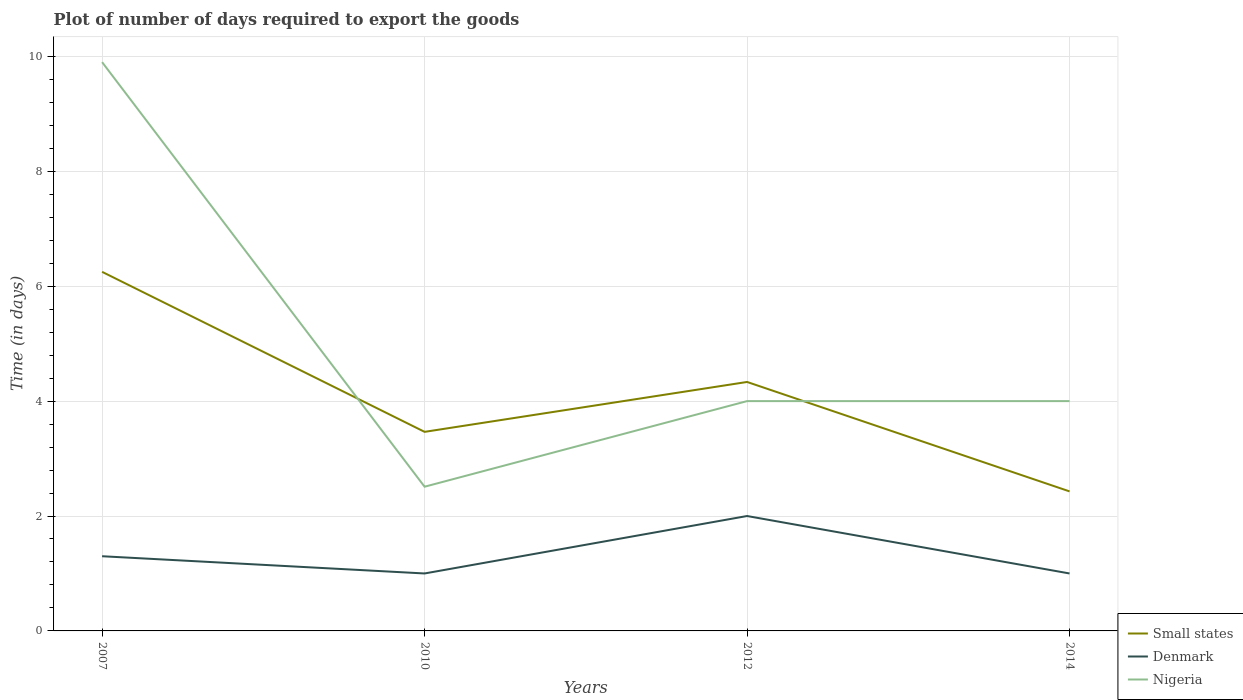How many different coloured lines are there?
Give a very brief answer. 3. Is the number of lines equal to the number of legend labels?
Keep it short and to the point. Yes. Across all years, what is the maximum time required to export goods in Small states?
Offer a terse response. 2.43. What is the total time required to export goods in Small states in the graph?
Ensure brevity in your answer.  3.82. What is the difference between the highest and the second highest time required to export goods in Nigeria?
Provide a succinct answer. 7.39. What is the difference between the highest and the lowest time required to export goods in Denmark?
Give a very brief answer. 1. What is the difference between two consecutive major ticks on the Y-axis?
Your answer should be compact. 2. What is the title of the graph?
Your response must be concise. Plot of number of days required to export the goods. Does "Algeria" appear as one of the legend labels in the graph?
Provide a short and direct response. No. What is the label or title of the X-axis?
Provide a short and direct response. Years. What is the label or title of the Y-axis?
Your answer should be very brief. Time (in days). What is the Time (in days) of Small states in 2007?
Your answer should be very brief. 6.25. What is the Time (in days) of Small states in 2010?
Provide a short and direct response. 3.46. What is the Time (in days) in Nigeria in 2010?
Your response must be concise. 2.51. What is the Time (in days) in Small states in 2012?
Your answer should be very brief. 4.33. What is the Time (in days) of Nigeria in 2012?
Your answer should be very brief. 4. What is the Time (in days) in Small states in 2014?
Give a very brief answer. 2.43. What is the Time (in days) in Denmark in 2014?
Give a very brief answer. 1. Across all years, what is the maximum Time (in days) in Small states?
Give a very brief answer. 6.25. Across all years, what is the minimum Time (in days) of Small states?
Your answer should be very brief. 2.43. Across all years, what is the minimum Time (in days) of Denmark?
Your response must be concise. 1. Across all years, what is the minimum Time (in days) of Nigeria?
Your answer should be very brief. 2.51. What is the total Time (in days) of Small states in the graph?
Provide a short and direct response. 16.48. What is the total Time (in days) in Denmark in the graph?
Your answer should be compact. 5.3. What is the total Time (in days) of Nigeria in the graph?
Offer a very short reply. 20.41. What is the difference between the Time (in days) in Small states in 2007 and that in 2010?
Your answer should be compact. 2.79. What is the difference between the Time (in days) of Denmark in 2007 and that in 2010?
Ensure brevity in your answer.  0.3. What is the difference between the Time (in days) in Nigeria in 2007 and that in 2010?
Give a very brief answer. 7.39. What is the difference between the Time (in days) of Small states in 2007 and that in 2012?
Provide a short and direct response. 1.92. What is the difference between the Time (in days) in Denmark in 2007 and that in 2012?
Ensure brevity in your answer.  -0.7. What is the difference between the Time (in days) in Small states in 2007 and that in 2014?
Your response must be concise. 3.82. What is the difference between the Time (in days) of Denmark in 2007 and that in 2014?
Provide a short and direct response. 0.3. What is the difference between the Time (in days) in Nigeria in 2007 and that in 2014?
Offer a very short reply. 5.9. What is the difference between the Time (in days) of Small states in 2010 and that in 2012?
Offer a terse response. -0.87. What is the difference between the Time (in days) in Nigeria in 2010 and that in 2012?
Your response must be concise. -1.49. What is the difference between the Time (in days) in Small states in 2010 and that in 2014?
Offer a terse response. 1.04. What is the difference between the Time (in days) of Nigeria in 2010 and that in 2014?
Provide a short and direct response. -1.49. What is the difference between the Time (in days) of Small states in 2012 and that in 2014?
Provide a short and direct response. 1.9. What is the difference between the Time (in days) of Small states in 2007 and the Time (in days) of Denmark in 2010?
Keep it short and to the point. 5.25. What is the difference between the Time (in days) of Small states in 2007 and the Time (in days) of Nigeria in 2010?
Your response must be concise. 3.74. What is the difference between the Time (in days) in Denmark in 2007 and the Time (in days) in Nigeria in 2010?
Provide a short and direct response. -1.21. What is the difference between the Time (in days) of Small states in 2007 and the Time (in days) of Denmark in 2012?
Offer a very short reply. 4.25. What is the difference between the Time (in days) in Small states in 2007 and the Time (in days) in Nigeria in 2012?
Make the answer very short. 2.25. What is the difference between the Time (in days) of Small states in 2007 and the Time (in days) of Denmark in 2014?
Your answer should be compact. 5.25. What is the difference between the Time (in days) of Small states in 2007 and the Time (in days) of Nigeria in 2014?
Your answer should be compact. 2.25. What is the difference between the Time (in days) in Denmark in 2007 and the Time (in days) in Nigeria in 2014?
Offer a terse response. -2.7. What is the difference between the Time (in days) in Small states in 2010 and the Time (in days) in Denmark in 2012?
Give a very brief answer. 1.47. What is the difference between the Time (in days) in Small states in 2010 and the Time (in days) in Nigeria in 2012?
Offer a terse response. -0.54. What is the difference between the Time (in days) in Denmark in 2010 and the Time (in days) in Nigeria in 2012?
Provide a succinct answer. -3. What is the difference between the Time (in days) in Small states in 2010 and the Time (in days) in Denmark in 2014?
Offer a terse response. 2.46. What is the difference between the Time (in days) of Small states in 2010 and the Time (in days) of Nigeria in 2014?
Ensure brevity in your answer.  -0.54. What is the difference between the Time (in days) of Denmark in 2010 and the Time (in days) of Nigeria in 2014?
Your answer should be compact. -3. What is the difference between the Time (in days) in Small states in 2012 and the Time (in days) in Nigeria in 2014?
Make the answer very short. 0.33. What is the difference between the Time (in days) of Denmark in 2012 and the Time (in days) of Nigeria in 2014?
Ensure brevity in your answer.  -2. What is the average Time (in days) of Small states per year?
Make the answer very short. 4.12. What is the average Time (in days) in Denmark per year?
Ensure brevity in your answer.  1.32. What is the average Time (in days) of Nigeria per year?
Give a very brief answer. 5.1. In the year 2007, what is the difference between the Time (in days) in Small states and Time (in days) in Denmark?
Keep it short and to the point. 4.95. In the year 2007, what is the difference between the Time (in days) in Small states and Time (in days) in Nigeria?
Offer a very short reply. -3.65. In the year 2007, what is the difference between the Time (in days) of Denmark and Time (in days) of Nigeria?
Give a very brief answer. -8.6. In the year 2010, what is the difference between the Time (in days) in Small states and Time (in days) in Denmark?
Offer a terse response. 2.46. In the year 2010, what is the difference between the Time (in days) in Small states and Time (in days) in Nigeria?
Your answer should be very brief. 0.95. In the year 2010, what is the difference between the Time (in days) in Denmark and Time (in days) in Nigeria?
Make the answer very short. -1.51. In the year 2012, what is the difference between the Time (in days) of Small states and Time (in days) of Denmark?
Ensure brevity in your answer.  2.33. In the year 2012, what is the difference between the Time (in days) in Small states and Time (in days) in Nigeria?
Provide a short and direct response. 0.33. In the year 2014, what is the difference between the Time (in days) of Small states and Time (in days) of Denmark?
Make the answer very short. 1.43. In the year 2014, what is the difference between the Time (in days) of Small states and Time (in days) of Nigeria?
Ensure brevity in your answer.  -1.57. What is the ratio of the Time (in days) in Small states in 2007 to that in 2010?
Your answer should be very brief. 1.8. What is the ratio of the Time (in days) in Denmark in 2007 to that in 2010?
Offer a very short reply. 1.3. What is the ratio of the Time (in days) in Nigeria in 2007 to that in 2010?
Provide a succinct answer. 3.94. What is the ratio of the Time (in days) of Small states in 2007 to that in 2012?
Your answer should be compact. 1.44. What is the ratio of the Time (in days) in Denmark in 2007 to that in 2012?
Offer a very short reply. 0.65. What is the ratio of the Time (in days) of Nigeria in 2007 to that in 2012?
Give a very brief answer. 2.48. What is the ratio of the Time (in days) of Small states in 2007 to that in 2014?
Keep it short and to the point. 2.57. What is the ratio of the Time (in days) in Denmark in 2007 to that in 2014?
Your response must be concise. 1.3. What is the ratio of the Time (in days) of Nigeria in 2007 to that in 2014?
Ensure brevity in your answer.  2.48. What is the ratio of the Time (in days) of Small states in 2010 to that in 2012?
Keep it short and to the point. 0.8. What is the ratio of the Time (in days) in Denmark in 2010 to that in 2012?
Make the answer very short. 0.5. What is the ratio of the Time (in days) of Nigeria in 2010 to that in 2012?
Provide a succinct answer. 0.63. What is the ratio of the Time (in days) in Small states in 2010 to that in 2014?
Your response must be concise. 1.43. What is the ratio of the Time (in days) in Nigeria in 2010 to that in 2014?
Your answer should be very brief. 0.63. What is the ratio of the Time (in days) of Small states in 2012 to that in 2014?
Your answer should be very brief. 1.78. What is the ratio of the Time (in days) in Nigeria in 2012 to that in 2014?
Offer a terse response. 1. What is the difference between the highest and the second highest Time (in days) in Small states?
Provide a short and direct response. 1.92. What is the difference between the highest and the lowest Time (in days) in Small states?
Your answer should be very brief. 3.82. What is the difference between the highest and the lowest Time (in days) of Nigeria?
Your answer should be very brief. 7.39. 